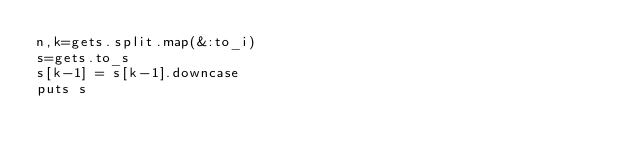<code> <loc_0><loc_0><loc_500><loc_500><_Ruby_>n,k=gets.split.map(&:to_i)
s=gets.to_s
s[k-1] = s[k-1].downcase
puts s</code> 